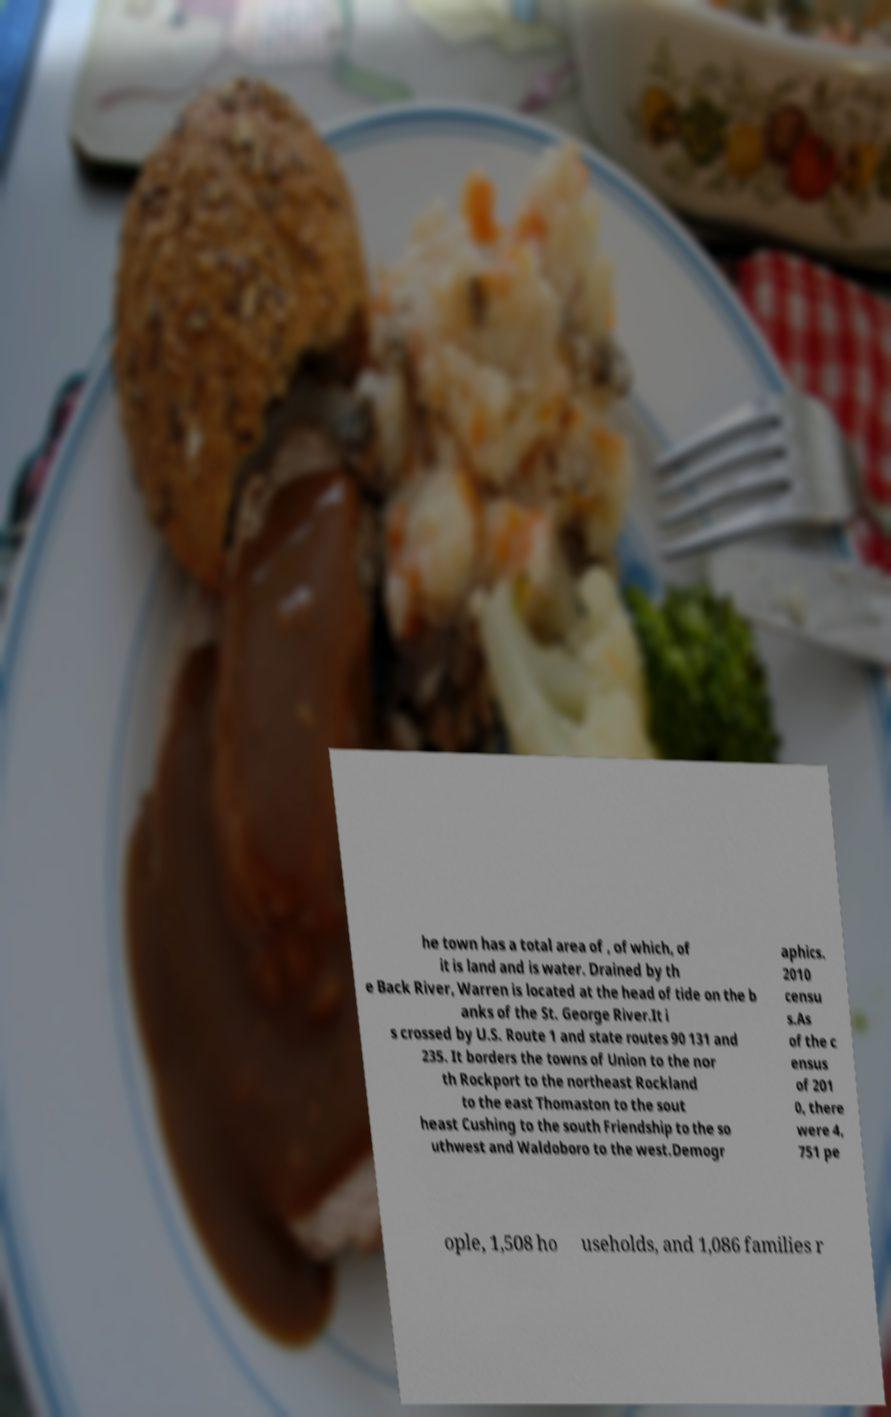Could you assist in decoding the text presented in this image and type it out clearly? he town has a total area of , of which, of it is land and is water. Drained by th e Back River, Warren is located at the head of tide on the b anks of the St. George River.It i s crossed by U.S. Route 1 and state routes 90 131 and 235. It borders the towns of Union to the nor th Rockport to the northeast Rockland to the east Thomaston to the sout heast Cushing to the south Friendship to the so uthwest and Waldoboro to the west.Demogr aphics. 2010 censu s.As of the c ensus of 201 0, there were 4, 751 pe ople, 1,508 ho useholds, and 1,086 families r 